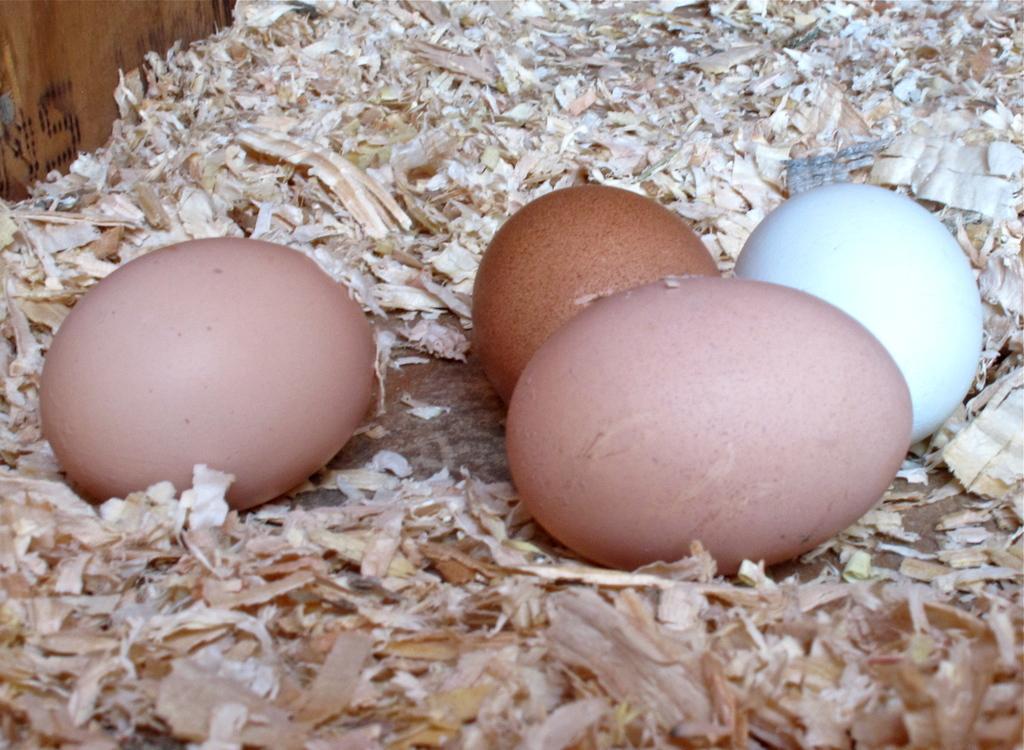Describe this image in one or two sentences. In this image we can see some eggs placed on the surface. We can also see the saw dust around them and a wooden board with some text on it. 